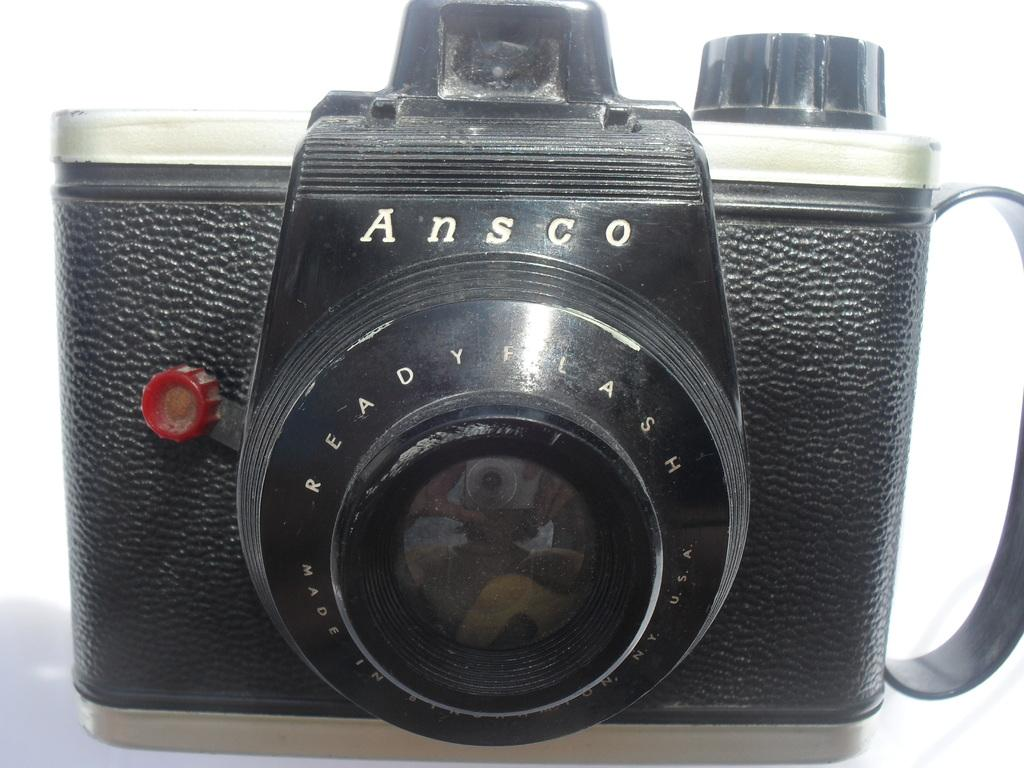What object is the main subject of the image? There is a camera in the image. What color is the camera? The camera is black in color. Where is the camera located in the image? The camera is on the floor. How does the camera show respect to the dock in the image? There is no dock present in the image, and therefore the camera cannot show respect to it. 